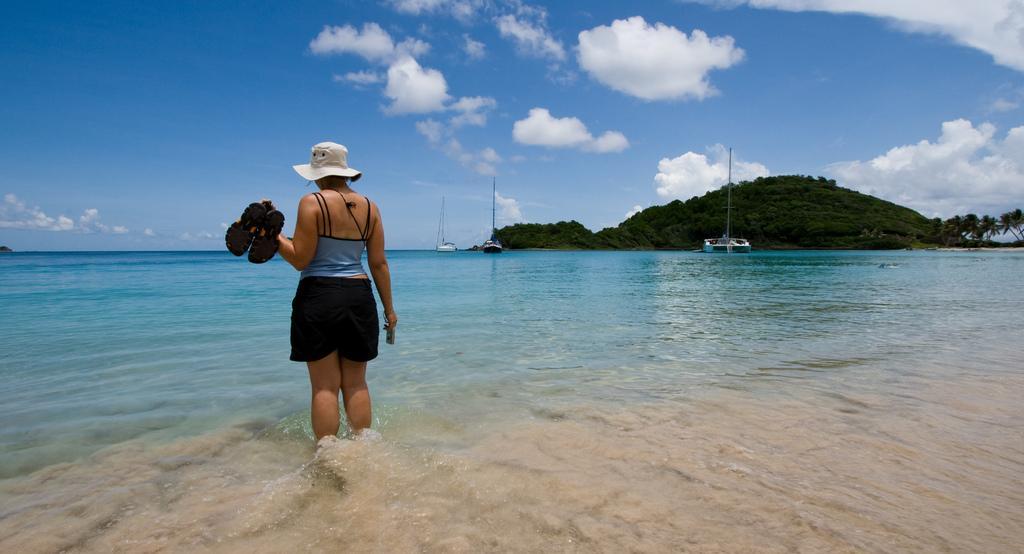Could you give a brief overview of what you see in this image? As we can see in the image there is water, a woman wearing white color hat and holding shoes. In the background there are boats and trees. At the top there is sky and there are clouds. 